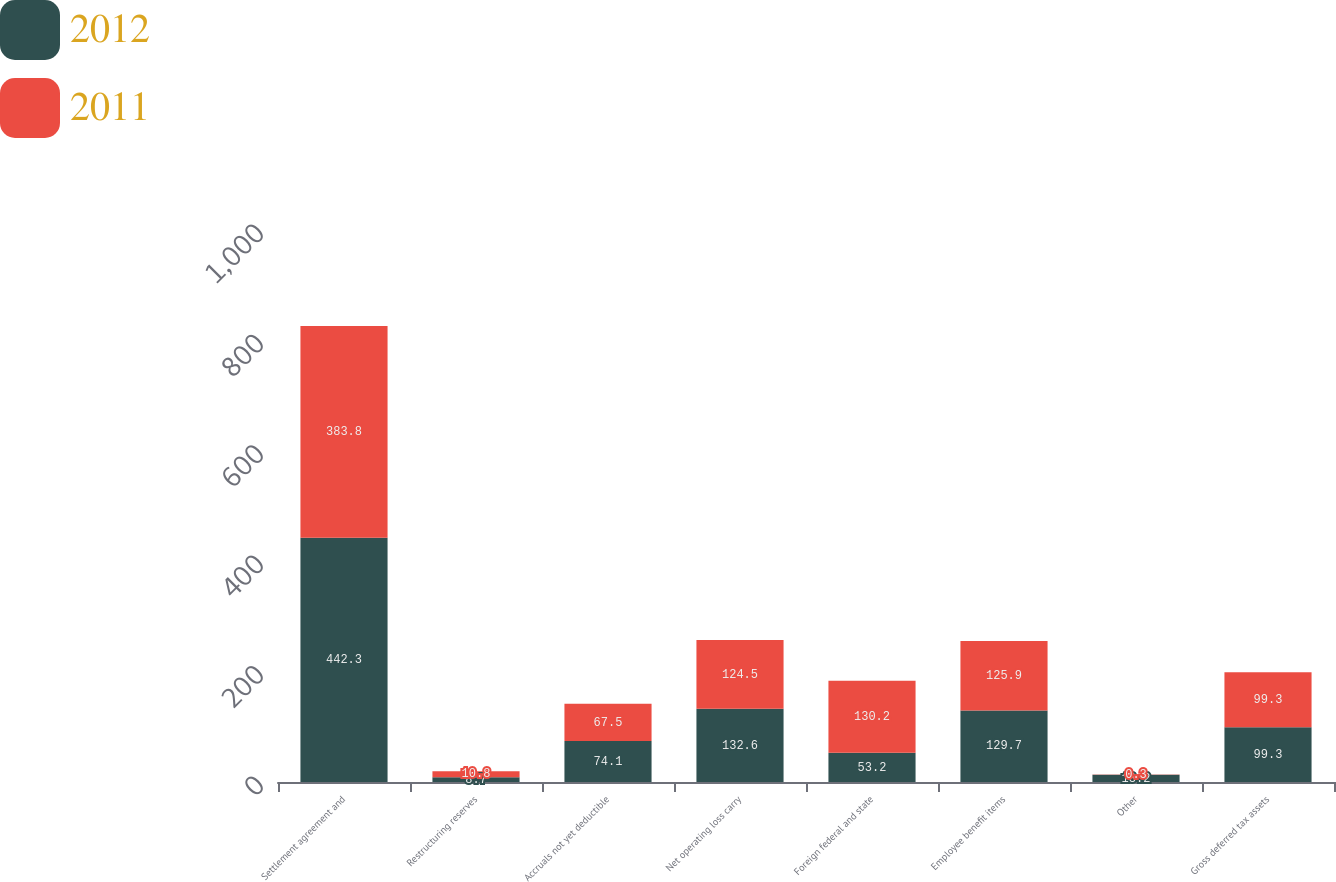<chart> <loc_0><loc_0><loc_500><loc_500><stacked_bar_chart><ecel><fcel>Settlement agreement and<fcel>Restructuring reserves<fcel>Accruals not yet deductible<fcel>Net operating loss carry<fcel>Foreign federal and state<fcel>Employee benefit items<fcel>Other<fcel>Gross deferred tax assets<nl><fcel>2012<fcel>442.3<fcel>8.7<fcel>74.1<fcel>132.6<fcel>53.2<fcel>129.7<fcel>13.2<fcel>99.3<nl><fcel>2011<fcel>383.8<fcel>10.8<fcel>67.5<fcel>124.5<fcel>130.2<fcel>125.9<fcel>0.3<fcel>99.3<nl></chart> 